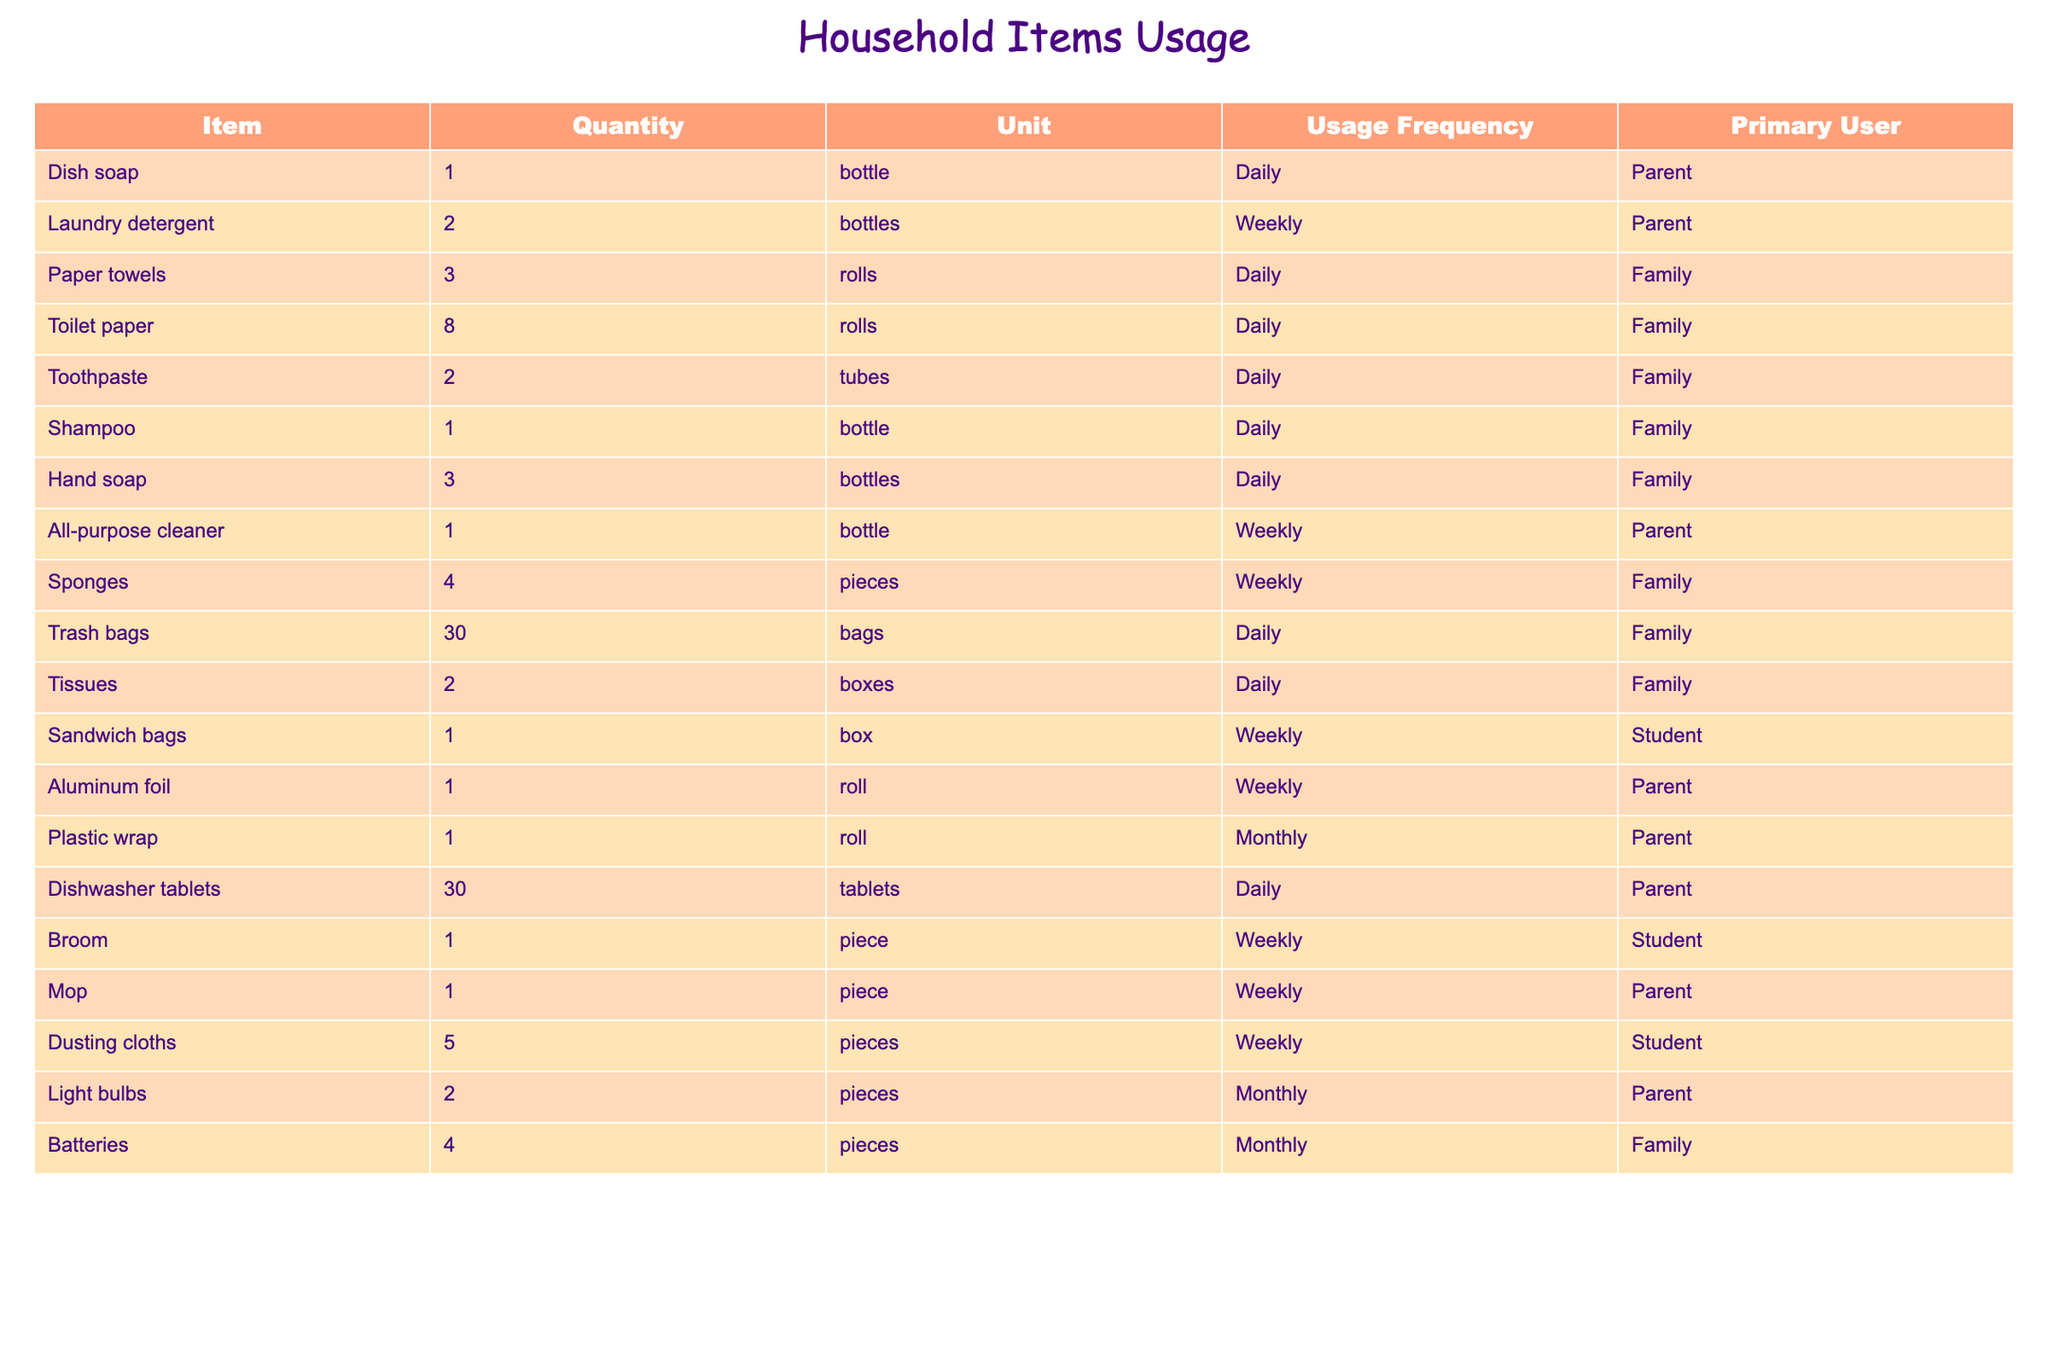What is the total quantity of paper towels used in a month? The table shows that there are 3 rolls of paper towels used daily. Over a month, this amounts to 3 rolls x 30 days = 90 rolls.
Answer: 90 rolls How many types of items are used daily by the family? By examining the table, I can find the items with a usage frequency marked as 'Daily.' These items are dish soap, paper towels, toilet paper, toothpaste, shampoo, hand soap, trash bags, tissues, and dishwasher tablets, totaling 8 types.
Answer: 8 Is aluminum foil used more frequently than sandwich bags? Aluminum foil is listed as being used weekly while sandwich bags are also listed as weekly. Since both have the same frequency, the answer is no, one is not used more frequently than the other.
Answer: No What is the combined quantity of laundry detergent and toothpaste used in a week? The table indicates that 2 bottles of laundry detergent are used weekly and 2 tubes of toothpaste are used daily. To find the weekly usage of toothpaste, we multiply 2 tubes by 7 days, resulting in 14 tubes weekly. Therefore, the combined quantity is 2 + 14 = 16.
Answer: 16 Which items are primarily used by the family? By inspecting the table, the items marked as primarily used by the family include paper towels, toilet paper, toothpaste, shampoo, hand soap, trash bags, tissues, sponges, and batteries. This identifies 8 items as primarily used by the family.
Answer: 8 items What is the total number of rolls of toilet paper and paper towels combined used in a week? The table shows that 3 rolls of paper towels are used daily and 8 rolls of toilet paper daily. For weekly usage, paper towels total 3 x 7 = 21 rolls and toilet paper totals 8 x 7 = 56 rolls. Adding these, 21 + 56 = 77 rolls combined in a week.
Answer: 77 rolls Does the student use more types of items compared to the parent? The table indicates that the student uses 3 types of items: sandwich bags, broom, and dusting cloths, while the parent uses 6 types: dish soap, laundry detergent, all-purpose cleaner, aluminum foil, plastic wrap, and mop. Therefore, the parent uses more types.
Answer: No What is the total number of cleaning items used weekly? From the table, the weekly cleaning items include laundry detergent (2 bottles), all-purpose cleaner (1 bottle), sponges (4 pieces), and mop (1 piece). The total is 2 + 1 + 4 + 1 = 8 cleaning items used weekly.
Answer: 8 items How many items have a monthly usage frequency? Looking through the table, there are 3 items with a monthly usage frequency: plastic wrap, light bulbs, and batteries, totaling 3 items used monthly.
Answer: 3 items 